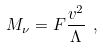Convert formula to latex. <formula><loc_0><loc_0><loc_500><loc_500>M _ { \nu } = F \frac { v ^ { 2 } } { \Lambda } \ ,</formula> 